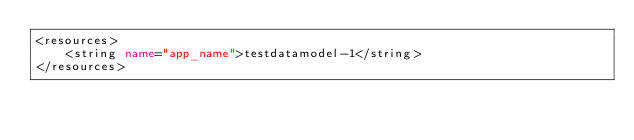Convert code to text. <code><loc_0><loc_0><loc_500><loc_500><_XML_><resources>
    <string name="app_name">testdatamodel-1</string>
</resources>
</code> 